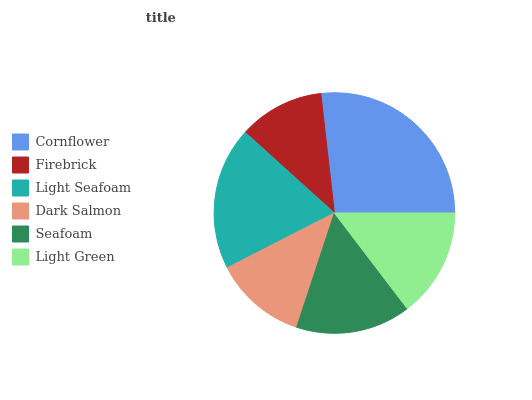Is Firebrick the minimum?
Answer yes or no. Yes. Is Cornflower the maximum?
Answer yes or no. Yes. Is Light Seafoam the minimum?
Answer yes or no. No. Is Light Seafoam the maximum?
Answer yes or no. No. Is Light Seafoam greater than Firebrick?
Answer yes or no. Yes. Is Firebrick less than Light Seafoam?
Answer yes or no. Yes. Is Firebrick greater than Light Seafoam?
Answer yes or no. No. Is Light Seafoam less than Firebrick?
Answer yes or no. No. Is Seafoam the high median?
Answer yes or no. Yes. Is Light Green the low median?
Answer yes or no. Yes. Is Light Green the high median?
Answer yes or no. No. Is Dark Salmon the low median?
Answer yes or no. No. 